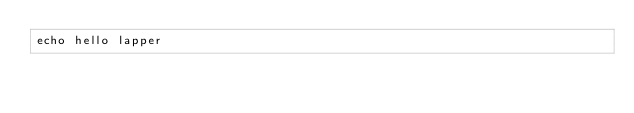Convert code to text. <code><loc_0><loc_0><loc_500><loc_500><_Bash_>echo hello lapper 
</code> 